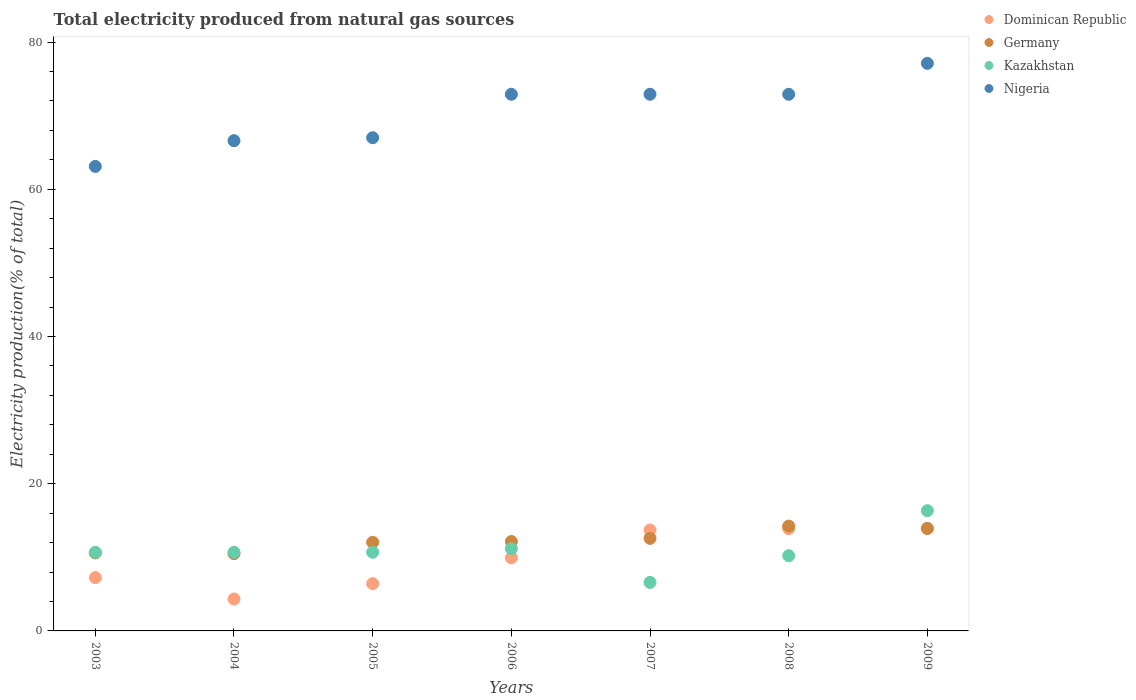What is the total electricity produced in Kazakhstan in 2009?
Your answer should be very brief. 16.33. Across all years, what is the maximum total electricity produced in Germany?
Provide a short and direct response. 14.24. Across all years, what is the minimum total electricity produced in Kazakhstan?
Give a very brief answer. 6.59. What is the total total electricity produced in Nigeria in the graph?
Offer a terse response. 492.5. What is the difference between the total electricity produced in Nigeria in 2007 and that in 2008?
Provide a short and direct response. 0. What is the difference between the total electricity produced in Germany in 2005 and the total electricity produced in Dominican Republic in 2008?
Your answer should be very brief. -1.86. What is the average total electricity produced in Kazakhstan per year?
Offer a very short reply. 10.91. In the year 2007, what is the difference between the total electricity produced in Kazakhstan and total electricity produced in Dominican Republic?
Your answer should be very brief. -7.12. In how many years, is the total electricity produced in Kazakhstan greater than 40 %?
Offer a terse response. 0. What is the ratio of the total electricity produced in Dominican Republic in 2003 to that in 2008?
Offer a very short reply. 0.52. Is the difference between the total electricity produced in Kazakhstan in 2003 and 2006 greater than the difference between the total electricity produced in Dominican Republic in 2003 and 2006?
Provide a succinct answer. Yes. What is the difference between the highest and the second highest total electricity produced in Germany?
Provide a short and direct response. 0.31. What is the difference between the highest and the lowest total electricity produced in Dominican Republic?
Your response must be concise. 9.57. Is the sum of the total electricity produced in Germany in 2003 and 2008 greater than the maximum total electricity produced in Dominican Republic across all years?
Provide a short and direct response. Yes. Is it the case that in every year, the sum of the total electricity produced in Germany and total electricity produced in Kazakhstan  is greater than the total electricity produced in Dominican Republic?
Keep it short and to the point. Yes. Does the total electricity produced in Dominican Republic monotonically increase over the years?
Provide a succinct answer. No. How many years are there in the graph?
Provide a short and direct response. 7. What is the difference between two consecutive major ticks on the Y-axis?
Your answer should be very brief. 20. Are the values on the major ticks of Y-axis written in scientific E-notation?
Your answer should be compact. No. Does the graph contain any zero values?
Keep it short and to the point. No. Does the graph contain grids?
Offer a terse response. No. Where does the legend appear in the graph?
Keep it short and to the point. Top right. How many legend labels are there?
Make the answer very short. 4. What is the title of the graph?
Your answer should be very brief. Total electricity produced from natural gas sources. Does "Guyana" appear as one of the legend labels in the graph?
Your response must be concise. No. What is the label or title of the X-axis?
Your response must be concise. Years. What is the Electricity production(% of total) of Dominican Republic in 2003?
Keep it short and to the point. 7.24. What is the Electricity production(% of total) of Germany in 2003?
Keep it short and to the point. 10.59. What is the Electricity production(% of total) of Kazakhstan in 2003?
Your answer should be very brief. 10.68. What is the Electricity production(% of total) of Nigeria in 2003?
Keep it short and to the point. 63.1. What is the Electricity production(% of total) of Dominican Republic in 2004?
Your answer should be very brief. 4.34. What is the Electricity production(% of total) in Germany in 2004?
Provide a short and direct response. 10.5. What is the Electricity production(% of total) in Kazakhstan in 2004?
Your answer should be compact. 10.68. What is the Electricity production(% of total) of Nigeria in 2004?
Offer a terse response. 66.6. What is the Electricity production(% of total) in Dominican Republic in 2005?
Your answer should be compact. 6.42. What is the Electricity production(% of total) in Germany in 2005?
Give a very brief answer. 12.04. What is the Electricity production(% of total) in Kazakhstan in 2005?
Give a very brief answer. 10.69. What is the Electricity production(% of total) of Nigeria in 2005?
Give a very brief answer. 67. What is the Electricity production(% of total) in Dominican Republic in 2006?
Provide a short and direct response. 9.94. What is the Electricity production(% of total) in Germany in 2006?
Provide a succinct answer. 12.14. What is the Electricity production(% of total) in Kazakhstan in 2006?
Make the answer very short. 11.17. What is the Electricity production(% of total) in Nigeria in 2006?
Make the answer very short. 72.9. What is the Electricity production(% of total) in Dominican Republic in 2007?
Your answer should be very brief. 13.72. What is the Electricity production(% of total) of Germany in 2007?
Give a very brief answer. 12.57. What is the Electricity production(% of total) in Kazakhstan in 2007?
Your answer should be compact. 6.59. What is the Electricity production(% of total) in Nigeria in 2007?
Your answer should be very brief. 72.9. What is the Electricity production(% of total) of Dominican Republic in 2008?
Provide a short and direct response. 13.9. What is the Electricity production(% of total) in Germany in 2008?
Give a very brief answer. 14.24. What is the Electricity production(% of total) in Kazakhstan in 2008?
Your answer should be compact. 10.22. What is the Electricity production(% of total) of Nigeria in 2008?
Your response must be concise. 72.9. What is the Electricity production(% of total) of Dominican Republic in 2009?
Provide a succinct answer. 13.91. What is the Electricity production(% of total) in Germany in 2009?
Your answer should be very brief. 13.93. What is the Electricity production(% of total) in Kazakhstan in 2009?
Your response must be concise. 16.33. What is the Electricity production(% of total) in Nigeria in 2009?
Your answer should be compact. 77.1. Across all years, what is the maximum Electricity production(% of total) in Dominican Republic?
Offer a terse response. 13.91. Across all years, what is the maximum Electricity production(% of total) in Germany?
Your response must be concise. 14.24. Across all years, what is the maximum Electricity production(% of total) of Kazakhstan?
Make the answer very short. 16.33. Across all years, what is the maximum Electricity production(% of total) in Nigeria?
Provide a short and direct response. 77.1. Across all years, what is the minimum Electricity production(% of total) in Dominican Republic?
Offer a very short reply. 4.34. Across all years, what is the minimum Electricity production(% of total) in Germany?
Your answer should be compact. 10.5. Across all years, what is the minimum Electricity production(% of total) of Kazakhstan?
Give a very brief answer. 6.59. Across all years, what is the minimum Electricity production(% of total) of Nigeria?
Provide a succinct answer. 63.1. What is the total Electricity production(% of total) of Dominican Republic in the graph?
Your answer should be very brief. 69.46. What is the total Electricity production(% of total) of Germany in the graph?
Offer a very short reply. 86.02. What is the total Electricity production(% of total) in Kazakhstan in the graph?
Your answer should be very brief. 76.36. What is the total Electricity production(% of total) of Nigeria in the graph?
Offer a very short reply. 492.5. What is the difference between the Electricity production(% of total) in Dominican Republic in 2003 and that in 2004?
Keep it short and to the point. 2.91. What is the difference between the Electricity production(% of total) in Germany in 2003 and that in 2004?
Give a very brief answer. 0.09. What is the difference between the Electricity production(% of total) of Kazakhstan in 2003 and that in 2004?
Make the answer very short. -0. What is the difference between the Electricity production(% of total) in Nigeria in 2003 and that in 2004?
Give a very brief answer. -3.5. What is the difference between the Electricity production(% of total) of Dominican Republic in 2003 and that in 2005?
Your response must be concise. 0.82. What is the difference between the Electricity production(% of total) of Germany in 2003 and that in 2005?
Keep it short and to the point. -1.44. What is the difference between the Electricity production(% of total) of Kazakhstan in 2003 and that in 2005?
Make the answer very short. -0.01. What is the difference between the Electricity production(% of total) of Nigeria in 2003 and that in 2005?
Offer a terse response. -3.9. What is the difference between the Electricity production(% of total) of Dominican Republic in 2003 and that in 2006?
Your answer should be compact. -2.69. What is the difference between the Electricity production(% of total) of Germany in 2003 and that in 2006?
Give a very brief answer. -1.55. What is the difference between the Electricity production(% of total) of Kazakhstan in 2003 and that in 2006?
Offer a very short reply. -0.49. What is the difference between the Electricity production(% of total) of Nigeria in 2003 and that in 2006?
Your answer should be very brief. -9.8. What is the difference between the Electricity production(% of total) of Dominican Republic in 2003 and that in 2007?
Make the answer very short. -6.47. What is the difference between the Electricity production(% of total) of Germany in 2003 and that in 2007?
Offer a terse response. -1.98. What is the difference between the Electricity production(% of total) in Kazakhstan in 2003 and that in 2007?
Your answer should be compact. 4.09. What is the difference between the Electricity production(% of total) in Nigeria in 2003 and that in 2007?
Offer a terse response. -9.8. What is the difference between the Electricity production(% of total) of Dominican Republic in 2003 and that in 2008?
Your answer should be compact. -6.66. What is the difference between the Electricity production(% of total) of Germany in 2003 and that in 2008?
Offer a terse response. -3.65. What is the difference between the Electricity production(% of total) of Kazakhstan in 2003 and that in 2008?
Your answer should be compact. 0.46. What is the difference between the Electricity production(% of total) of Nigeria in 2003 and that in 2008?
Give a very brief answer. -9.8. What is the difference between the Electricity production(% of total) of Dominican Republic in 2003 and that in 2009?
Give a very brief answer. -6.66. What is the difference between the Electricity production(% of total) in Germany in 2003 and that in 2009?
Offer a very short reply. -3.34. What is the difference between the Electricity production(% of total) of Kazakhstan in 2003 and that in 2009?
Keep it short and to the point. -5.66. What is the difference between the Electricity production(% of total) of Nigeria in 2003 and that in 2009?
Keep it short and to the point. -14. What is the difference between the Electricity production(% of total) of Dominican Republic in 2004 and that in 2005?
Offer a very short reply. -2.09. What is the difference between the Electricity production(% of total) of Germany in 2004 and that in 2005?
Your response must be concise. -1.54. What is the difference between the Electricity production(% of total) of Kazakhstan in 2004 and that in 2005?
Your response must be concise. -0.01. What is the difference between the Electricity production(% of total) in Nigeria in 2004 and that in 2005?
Keep it short and to the point. -0.4. What is the difference between the Electricity production(% of total) of Dominican Republic in 2004 and that in 2006?
Offer a very short reply. -5.6. What is the difference between the Electricity production(% of total) of Germany in 2004 and that in 2006?
Provide a succinct answer. -1.64. What is the difference between the Electricity production(% of total) in Kazakhstan in 2004 and that in 2006?
Keep it short and to the point. -0.49. What is the difference between the Electricity production(% of total) of Nigeria in 2004 and that in 2006?
Your answer should be compact. -6.3. What is the difference between the Electricity production(% of total) in Dominican Republic in 2004 and that in 2007?
Make the answer very short. -9.38. What is the difference between the Electricity production(% of total) in Germany in 2004 and that in 2007?
Keep it short and to the point. -2.07. What is the difference between the Electricity production(% of total) of Kazakhstan in 2004 and that in 2007?
Your answer should be very brief. 4.09. What is the difference between the Electricity production(% of total) of Nigeria in 2004 and that in 2007?
Provide a succinct answer. -6.3. What is the difference between the Electricity production(% of total) of Dominican Republic in 2004 and that in 2008?
Make the answer very short. -9.56. What is the difference between the Electricity production(% of total) of Germany in 2004 and that in 2008?
Make the answer very short. -3.74. What is the difference between the Electricity production(% of total) in Kazakhstan in 2004 and that in 2008?
Give a very brief answer. 0.46. What is the difference between the Electricity production(% of total) of Nigeria in 2004 and that in 2008?
Your answer should be very brief. -6.3. What is the difference between the Electricity production(% of total) in Dominican Republic in 2004 and that in 2009?
Provide a succinct answer. -9.57. What is the difference between the Electricity production(% of total) in Germany in 2004 and that in 2009?
Keep it short and to the point. -3.43. What is the difference between the Electricity production(% of total) of Kazakhstan in 2004 and that in 2009?
Your response must be concise. -5.66. What is the difference between the Electricity production(% of total) in Nigeria in 2004 and that in 2009?
Your answer should be compact. -10.5. What is the difference between the Electricity production(% of total) in Dominican Republic in 2005 and that in 2006?
Keep it short and to the point. -3.51. What is the difference between the Electricity production(% of total) in Germany in 2005 and that in 2006?
Offer a terse response. -0.11. What is the difference between the Electricity production(% of total) in Kazakhstan in 2005 and that in 2006?
Provide a succinct answer. -0.48. What is the difference between the Electricity production(% of total) of Nigeria in 2005 and that in 2006?
Ensure brevity in your answer.  -5.9. What is the difference between the Electricity production(% of total) of Dominican Republic in 2005 and that in 2007?
Make the answer very short. -7.29. What is the difference between the Electricity production(% of total) in Germany in 2005 and that in 2007?
Keep it short and to the point. -0.54. What is the difference between the Electricity production(% of total) of Kazakhstan in 2005 and that in 2007?
Offer a terse response. 4.1. What is the difference between the Electricity production(% of total) of Nigeria in 2005 and that in 2007?
Your response must be concise. -5.9. What is the difference between the Electricity production(% of total) in Dominican Republic in 2005 and that in 2008?
Your answer should be very brief. -7.48. What is the difference between the Electricity production(% of total) of Germany in 2005 and that in 2008?
Keep it short and to the point. -2.21. What is the difference between the Electricity production(% of total) in Kazakhstan in 2005 and that in 2008?
Your answer should be very brief. 0.47. What is the difference between the Electricity production(% of total) of Nigeria in 2005 and that in 2008?
Provide a succinct answer. -5.9. What is the difference between the Electricity production(% of total) of Dominican Republic in 2005 and that in 2009?
Your answer should be very brief. -7.48. What is the difference between the Electricity production(% of total) in Germany in 2005 and that in 2009?
Make the answer very short. -1.89. What is the difference between the Electricity production(% of total) of Kazakhstan in 2005 and that in 2009?
Offer a terse response. -5.64. What is the difference between the Electricity production(% of total) in Nigeria in 2005 and that in 2009?
Make the answer very short. -10.1. What is the difference between the Electricity production(% of total) of Dominican Republic in 2006 and that in 2007?
Your answer should be very brief. -3.78. What is the difference between the Electricity production(% of total) in Germany in 2006 and that in 2007?
Make the answer very short. -0.43. What is the difference between the Electricity production(% of total) of Kazakhstan in 2006 and that in 2007?
Keep it short and to the point. 4.58. What is the difference between the Electricity production(% of total) in Nigeria in 2006 and that in 2007?
Provide a succinct answer. -0. What is the difference between the Electricity production(% of total) in Dominican Republic in 2006 and that in 2008?
Provide a succinct answer. -3.96. What is the difference between the Electricity production(% of total) of Germany in 2006 and that in 2008?
Offer a terse response. -2.1. What is the difference between the Electricity production(% of total) of Kazakhstan in 2006 and that in 2008?
Your response must be concise. 0.95. What is the difference between the Electricity production(% of total) of Nigeria in 2006 and that in 2008?
Your answer should be very brief. 0. What is the difference between the Electricity production(% of total) of Dominican Republic in 2006 and that in 2009?
Your answer should be compact. -3.97. What is the difference between the Electricity production(% of total) in Germany in 2006 and that in 2009?
Provide a succinct answer. -1.78. What is the difference between the Electricity production(% of total) of Kazakhstan in 2006 and that in 2009?
Keep it short and to the point. -5.17. What is the difference between the Electricity production(% of total) in Nigeria in 2006 and that in 2009?
Ensure brevity in your answer.  -4.2. What is the difference between the Electricity production(% of total) of Dominican Republic in 2007 and that in 2008?
Your answer should be very brief. -0.18. What is the difference between the Electricity production(% of total) of Germany in 2007 and that in 2008?
Provide a succinct answer. -1.67. What is the difference between the Electricity production(% of total) in Kazakhstan in 2007 and that in 2008?
Your answer should be very brief. -3.63. What is the difference between the Electricity production(% of total) of Nigeria in 2007 and that in 2008?
Keep it short and to the point. 0. What is the difference between the Electricity production(% of total) of Dominican Republic in 2007 and that in 2009?
Offer a very short reply. -0.19. What is the difference between the Electricity production(% of total) in Germany in 2007 and that in 2009?
Your response must be concise. -1.35. What is the difference between the Electricity production(% of total) of Kazakhstan in 2007 and that in 2009?
Make the answer very short. -9.74. What is the difference between the Electricity production(% of total) of Nigeria in 2007 and that in 2009?
Your answer should be very brief. -4.2. What is the difference between the Electricity production(% of total) of Dominican Republic in 2008 and that in 2009?
Give a very brief answer. -0.01. What is the difference between the Electricity production(% of total) in Germany in 2008 and that in 2009?
Keep it short and to the point. 0.31. What is the difference between the Electricity production(% of total) of Kazakhstan in 2008 and that in 2009?
Your response must be concise. -6.12. What is the difference between the Electricity production(% of total) in Nigeria in 2008 and that in 2009?
Your answer should be very brief. -4.2. What is the difference between the Electricity production(% of total) of Dominican Republic in 2003 and the Electricity production(% of total) of Germany in 2004?
Offer a terse response. -3.26. What is the difference between the Electricity production(% of total) of Dominican Republic in 2003 and the Electricity production(% of total) of Kazakhstan in 2004?
Provide a short and direct response. -3.44. What is the difference between the Electricity production(% of total) in Dominican Republic in 2003 and the Electricity production(% of total) in Nigeria in 2004?
Keep it short and to the point. -59.36. What is the difference between the Electricity production(% of total) in Germany in 2003 and the Electricity production(% of total) in Kazakhstan in 2004?
Offer a very short reply. -0.09. What is the difference between the Electricity production(% of total) of Germany in 2003 and the Electricity production(% of total) of Nigeria in 2004?
Make the answer very short. -56.01. What is the difference between the Electricity production(% of total) in Kazakhstan in 2003 and the Electricity production(% of total) in Nigeria in 2004?
Keep it short and to the point. -55.92. What is the difference between the Electricity production(% of total) in Dominican Republic in 2003 and the Electricity production(% of total) in Germany in 2005?
Offer a very short reply. -4.79. What is the difference between the Electricity production(% of total) in Dominican Republic in 2003 and the Electricity production(% of total) in Kazakhstan in 2005?
Offer a very short reply. -3.45. What is the difference between the Electricity production(% of total) of Dominican Republic in 2003 and the Electricity production(% of total) of Nigeria in 2005?
Keep it short and to the point. -59.76. What is the difference between the Electricity production(% of total) in Germany in 2003 and the Electricity production(% of total) in Kazakhstan in 2005?
Offer a very short reply. -0.1. What is the difference between the Electricity production(% of total) of Germany in 2003 and the Electricity production(% of total) of Nigeria in 2005?
Your answer should be very brief. -56.41. What is the difference between the Electricity production(% of total) of Kazakhstan in 2003 and the Electricity production(% of total) of Nigeria in 2005?
Offer a very short reply. -56.32. What is the difference between the Electricity production(% of total) of Dominican Republic in 2003 and the Electricity production(% of total) of Germany in 2006?
Your answer should be compact. -4.9. What is the difference between the Electricity production(% of total) in Dominican Republic in 2003 and the Electricity production(% of total) in Kazakhstan in 2006?
Keep it short and to the point. -3.93. What is the difference between the Electricity production(% of total) in Dominican Republic in 2003 and the Electricity production(% of total) in Nigeria in 2006?
Make the answer very short. -65.66. What is the difference between the Electricity production(% of total) in Germany in 2003 and the Electricity production(% of total) in Kazakhstan in 2006?
Make the answer very short. -0.58. What is the difference between the Electricity production(% of total) in Germany in 2003 and the Electricity production(% of total) in Nigeria in 2006?
Your answer should be compact. -62.31. What is the difference between the Electricity production(% of total) in Kazakhstan in 2003 and the Electricity production(% of total) in Nigeria in 2006?
Your answer should be very brief. -62.22. What is the difference between the Electricity production(% of total) in Dominican Republic in 2003 and the Electricity production(% of total) in Germany in 2007?
Give a very brief answer. -5.33. What is the difference between the Electricity production(% of total) in Dominican Republic in 2003 and the Electricity production(% of total) in Kazakhstan in 2007?
Ensure brevity in your answer.  0.65. What is the difference between the Electricity production(% of total) in Dominican Republic in 2003 and the Electricity production(% of total) in Nigeria in 2007?
Give a very brief answer. -65.66. What is the difference between the Electricity production(% of total) of Germany in 2003 and the Electricity production(% of total) of Kazakhstan in 2007?
Provide a succinct answer. 4. What is the difference between the Electricity production(% of total) of Germany in 2003 and the Electricity production(% of total) of Nigeria in 2007?
Your response must be concise. -62.31. What is the difference between the Electricity production(% of total) in Kazakhstan in 2003 and the Electricity production(% of total) in Nigeria in 2007?
Your response must be concise. -62.22. What is the difference between the Electricity production(% of total) in Dominican Republic in 2003 and the Electricity production(% of total) in Germany in 2008?
Ensure brevity in your answer.  -7. What is the difference between the Electricity production(% of total) in Dominican Republic in 2003 and the Electricity production(% of total) in Kazakhstan in 2008?
Make the answer very short. -2.97. What is the difference between the Electricity production(% of total) in Dominican Republic in 2003 and the Electricity production(% of total) in Nigeria in 2008?
Your response must be concise. -65.66. What is the difference between the Electricity production(% of total) of Germany in 2003 and the Electricity production(% of total) of Kazakhstan in 2008?
Offer a very short reply. 0.38. What is the difference between the Electricity production(% of total) of Germany in 2003 and the Electricity production(% of total) of Nigeria in 2008?
Offer a terse response. -62.31. What is the difference between the Electricity production(% of total) in Kazakhstan in 2003 and the Electricity production(% of total) in Nigeria in 2008?
Provide a short and direct response. -62.22. What is the difference between the Electricity production(% of total) of Dominican Republic in 2003 and the Electricity production(% of total) of Germany in 2009?
Your response must be concise. -6.69. What is the difference between the Electricity production(% of total) of Dominican Republic in 2003 and the Electricity production(% of total) of Kazakhstan in 2009?
Offer a very short reply. -9.09. What is the difference between the Electricity production(% of total) in Dominican Republic in 2003 and the Electricity production(% of total) in Nigeria in 2009?
Offer a terse response. -69.86. What is the difference between the Electricity production(% of total) of Germany in 2003 and the Electricity production(% of total) of Kazakhstan in 2009?
Offer a terse response. -5.74. What is the difference between the Electricity production(% of total) in Germany in 2003 and the Electricity production(% of total) in Nigeria in 2009?
Offer a terse response. -66.51. What is the difference between the Electricity production(% of total) in Kazakhstan in 2003 and the Electricity production(% of total) in Nigeria in 2009?
Your answer should be very brief. -66.42. What is the difference between the Electricity production(% of total) of Dominican Republic in 2004 and the Electricity production(% of total) of Germany in 2005?
Your answer should be compact. -7.7. What is the difference between the Electricity production(% of total) in Dominican Republic in 2004 and the Electricity production(% of total) in Kazakhstan in 2005?
Keep it short and to the point. -6.35. What is the difference between the Electricity production(% of total) in Dominican Republic in 2004 and the Electricity production(% of total) in Nigeria in 2005?
Offer a very short reply. -62.66. What is the difference between the Electricity production(% of total) of Germany in 2004 and the Electricity production(% of total) of Kazakhstan in 2005?
Your answer should be very brief. -0.19. What is the difference between the Electricity production(% of total) of Germany in 2004 and the Electricity production(% of total) of Nigeria in 2005?
Provide a short and direct response. -56.5. What is the difference between the Electricity production(% of total) in Kazakhstan in 2004 and the Electricity production(% of total) in Nigeria in 2005?
Your answer should be very brief. -56.32. What is the difference between the Electricity production(% of total) of Dominican Republic in 2004 and the Electricity production(% of total) of Germany in 2006?
Give a very brief answer. -7.81. What is the difference between the Electricity production(% of total) in Dominican Republic in 2004 and the Electricity production(% of total) in Kazakhstan in 2006?
Offer a terse response. -6.83. What is the difference between the Electricity production(% of total) in Dominican Republic in 2004 and the Electricity production(% of total) in Nigeria in 2006?
Provide a short and direct response. -68.56. What is the difference between the Electricity production(% of total) in Germany in 2004 and the Electricity production(% of total) in Kazakhstan in 2006?
Your response must be concise. -0.67. What is the difference between the Electricity production(% of total) in Germany in 2004 and the Electricity production(% of total) in Nigeria in 2006?
Keep it short and to the point. -62.4. What is the difference between the Electricity production(% of total) in Kazakhstan in 2004 and the Electricity production(% of total) in Nigeria in 2006?
Provide a succinct answer. -62.22. What is the difference between the Electricity production(% of total) in Dominican Republic in 2004 and the Electricity production(% of total) in Germany in 2007?
Your response must be concise. -8.24. What is the difference between the Electricity production(% of total) of Dominican Republic in 2004 and the Electricity production(% of total) of Kazakhstan in 2007?
Keep it short and to the point. -2.25. What is the difference between the Electricity production(% of total) of Dominican Republic in 2004 and the Electricity production(% of total) of Nigeria in 2007?
Your answer should be compact. -68.56. What is the difference between the Electricity production(% of total) of Germany in 2004 and the Electricity production(% of total) of Kazakhstan in 2007?
Give a very brief answer. 3.91. What is the difference between the Electricity production(% of total) of Germany in 2004 and the Electricity production(% of total) of Nigeria in 2007?
Provide a succinct answer. -62.4. What is the difference between the Electricity production(% of total) in Kazakhstan in 2004 and the Electricity production(% of total) in Nigeria in 2007?
Offer a very short reply. -62.22. What is the difference between the Electricity production(% of total) of Dominican Republic in 2004 and the Electricity production(% of total) of Germany in 2008?
Keep it short and to the point. -9.91. What is the difference between the Electricity production(% of total) in Dominican Republic in 2004 and the Electricity production(% of total) in Kazakhstan in 2008?
Ensure brevity in your answer.  -5.88. What is the difference between the Electricity production(% of total) of Dominican Republic in 2004 and the Electricity production(% of total) of Nigeria in 2008?
Provide a succinct answer. -68.56. What is the difference between the Electricity production(% of total) of Germany in 2004 and the Electricity production(% of total) of Kazakhstan in 2008?
Offer a terse response. 0.28. What is the difference between the Electricity production(% of total) in Germany in 2004 and the Electricity production(% of total) in Nigeria in 2008?
Give a very brief answer. -62.4. What is the difference between the Electricity production(% of total) in Kazakhstan in 2004 and the Electricity production(% of total) in Nigeria in 2008?
Provide a succinct answer. -62.22. What is the difference between the Electricity production(% of total) in Dominican Republic in 2004 and the Electricity production(% of total) in Germany in 2009?
Your answer should be compact. -9.59. What is the difference between the Electricity production(% of total) in Dominican Republic in 2004 and the Electricity production(% of total) in Kazakhstan in 2009?
Make the answer very short. -12. What is the difference between the Electricity production(% of total) in Dominican Republic in 2004 and the Electricity production(% of total) in Nigeria in 2009?
Your answer should be very brief. -72.76. What is the difference between the Electricity production(% of total) in Germany in 2004 and the Electricity production(% of total) in Kazakhstan in 2009?
Provide a succinct answer. -5.83. What is the difference between the Electricity production(% of total) in Germany in 2004 and the Electricity production(% of total) in Nigeria in 2009?
Make the answer very short. -66.6. What is the difference between the Electricity production(% of total) in Kazakhstan in 2004 and the Electricity production(% of total) in Nigeria in 2009?
Your response must be concise. -66.42. What is the difference between the Electricity production(% of total) of Dominican Republic in 2005 and the Electricity production(% of total) of Germany in 2006?
Your answer should be very brief. -5.72. What is the difference between the Electricity production(% of total) of Dominican Republic in 2005 and the Electricity production(% of total) of Kazakhstan in 2006?
Your answer should be compact. -4.75. What is the difference between the Electricity production(% of total) in Dominican Republic in 2005 and the Electricity production(% of total) in Nigeria in 2006?
Your response must be concise. -66.48. What is the difference between the Electricity production(% of total) in Germany in 2005 and the Electricity production(% of total) in Kazakhstan in 2006?
Give a very brief answer. 0.87. What is the difference between the Electricity production(% of total) in Germany in 2005 and the Electricity production(% of total) in Nigeria in 2006?
Your answer should be very brief. -60.86. What is the difference between the Electricity production(% of total) of Kazakhstan in 2005 and the Electricity production(% of total) of Nigeria in 2006?
Offer a very short reply. -62.21. What is the difference between the Electricity production(% of total) in Dominican Republic in 2005 and the Electricity production(% of total) in Germany in 2007?
Give a very brief answer. -6.15. What is the difference between the Electricity production(% of total) of Dominican Republic in 2005 and the Electricity production(% of total) of Kazakhstan in 2007?
Your response must be concise. -0.17. What is the difference between the Electricity production(% of total) in Dominican Republic in 2005 and the Electricity production(% of total) in Nigeria in 2007?
Keep it short and to the point. -66.48. What is the difference between the Electricity production(% of total) in Germany in 2005 and the Electricity production(% of total) in Kazakhstan in 2007?
Offer a very short reply. 5.45. What is the difference between the Electricity production(% of total) in Germany in 2005 and the Electricity production(% of total) in Nigeria in 2007?
Provide a short and direct response. -60.86. What is the difference between the Electricity production(% of total) of Kazakhstan in 2005 and the Electricity production(% of total) of Nigeria in 2007?
Make the answer very short. -62.21. What is the difference between the Electricity production(% of total) of Dominican Republic in 2005 and the Electricity production(% of total) of Germany in 2008?
Keep it short and to the point. -7.82. What is the difference between the Electricity production(% of total) in Dominican Republic in 2005 and the Electricity production(% of total) in Kazakhstan in 2008?
Provide a succinct answer. -3.79. What is the difference between the Electricity production(% of total) in Dominican Republic in 2005 and the Electricity production(% of total) in Nigeria in 2008?
Keep it short and to the point. -66.48. What is the difference between the Electricity production(% of total) of Germany in 2005 and the Electricity production(% of total) of Kazakhstan in 2008?
Offer a very short reply. 1.82. What is the difference between the Electricity production(% of total) of Germany in 2005 and the Electricity production(% of total) of Nigeria in 2008?
Ensure brevity in your answer.  -60.86. What is the difference between the Electricity production(% of total) in Kazakhstan in 2005 and the Electricity production(% of total) in Nigeria in 2008?
Provide a succinct answer. -62.21. What is the difference between the Electricity production(% of total) of Dominican Republic in 2005 and the Electricity production(% of total) of Germany in 2009?
Your answer should be compact. -7.51. What is the difference between the Electricity production(% of total) of Dominican Republic in 2005 and the Electricity production(% of total) of Kazakhstan in 2009?
Offer a very short reply. -9.91. What is the difference between the Electricity production(% of total) in Dominican Republic in 2005 and the Electricity production(% of total) in Nigeria in 2009?
Your response must be concise. -70.68. What is the difference between the Electricity production(% of total) of Germany in 2005 and the Electricity production(% of total) of Kazakhstan in 2009?
Offer a very short reply. -4.3. What is the difference between the Electricity production(% of total) of Germany in 2005 and the Electricity production(% of total) of Nigeria in 2009?
Give a very brief answer. -65.06. What is the difference between the Electricity production(% of total) of Kazakhstan in 2005 and the Electricity production(% of total) of Nigeria in 2009?
Provide a short and direct response. -66.41. What is the difference between the Electricity production(% of total) in Dominican Republic in 2006 and the Electricity production(% of total) in Germany in 2007?
Ensure brevity in your answer.  -2.64. What is the difference between the Electricity production(% of total) in Dominican Republic in 2006 and the Electricity production(% of total) in Kazakhstan in 2007?
Offer a very short reply. 3.34. What is the difference between the Electricity production(% of total) of Dominican Republic in 2006 and the Electricity production(% of total) of Nigeria in 2007?
Your answer should be compact. -62.97. What is the difference between the Electricity production(% of total) of Germany in 2006 and the Electricity production(% of total) of Kazakhstan in 2007?
Provide a succinct answer. 5.55. What is the difference between the Electricity production(% of total) in Germany in 2006 and the Electricity production(% of total) in Nigeria in 2007?
Provide a short and direct response. -60.76. What is the difference between the Electricity production(% of total) of Kazakhstan in 2006 and the Electricity production(% of total) of Nigeria in 2007?
Give a very brief answer. -61.73. What is the difference between the Electricity production(% of total) in Dominican Republic in 2006 and the Electricity production(% of total) in Germany in 2008?
Your answer should be very brief. -4.31. What is the difference between the Electricity production(% of total) of Dominican Republic in 2006 and the Electricity production(% of total) of Kazakhstan in 2008?
Your answer should be compact. -0.28. What is the difference between the Electricity production(% of total) of Dominican Republic in 2006 and the Electricity production(% of total) of Nigeria in 2008?
Your answer should be very brief. -62.96. What is the difference between the Electricity production(% of total) in Germany in 2006 and the Electricity production(% of total) in Kazakhstan in 2008?
Offer a terse response. 1.93. What is the difference between the Electricity production(% of total) of Germany in 2006 and the Electricity production(% of total) of Nigeria in 2008?
Make the answer very short. -60.76. What is the difference between the Electricity production(% of total) in Kazakhstan in 2006 and the Electricity production(% of total) in Nigeria in 2008?
Ensure brevity in your answer.  -61.73. What is the difference between the Electricity production(% of total) in Dominican Republic in 2006 and the Electricity production(% of total) in Germany in 2009?
Keep it short and to the point. -3.99. What is the difference between the Electricity production(% of total) in Dominican Republic in 2006 and the Electricity production(% of total) in Kazakhstan in 2009?
Give a very brief answer. -6.4. What is the difference between the Electricity production(% of total) in Dominican Republic in 2006 and the Electricity production(% of total) in Nigeria in 2009?
Ensure brevity in your answer.  -67.16. What is the difference between the Electricity production(% of total) in Germany in 2006 and the Electricity production(% of total) in Kazakhstan in 2009?
Give a very brief answer. -4.19. What is the difference between the Electricity production(% of total) in Germany in 2006 and the Electricity production(% of total) in Nigeria in 2009?
Offer a terse response. -64.96. What is the difference between the Electricity production(% of total) of Kazakhstan in 2006 and the Electricity production(% of total) of Nigeria in 2009?
Keep it short and to the point. -65.93. What is the difference between the Electricity production(% of total) of Dominican Republic in 2007 and the Electricity production(% of total) of Germany in 2008?
Provide a succinct answer. -0.53. What is the difference between the Electricity production(% of total) in Dominican Republic in 2007 and the Electricity production(% of total) in Kazakhstan in 2008?
Your answer should be very brief. 3.5. What is the difference between the Electricity production(% of total) in Dominican Republic in 2007 and the Electricity production(% of total) in Nigeria in 2008?
Your response must be concise. -59.18. What is the difference between the Electricity production(% of total) of Germany in 2007 and the Electricity production(% of total) of Kazakhstan in 2008?
Your answer should be very brief. 2.36. What is the difference between the Electricity production(% of total) in Germany in 2007 and the Electricity production(% of total) in Nigeria in 2008?
Keep it short and to the point. -60.33. What is the difference between the Electricity production(% of total) in Kazakhstan in 2007 and the Electricity production(% of total) in Nigeria in 2008?
Provide a succinct answer. -66.31. What is the difference between the Electricity production(% of total) in Dominican Republic in 2007 and the Electricity production(% of total) in Germany in 2009?
Provide a succinct answer. -0.21. What is the difference between the Electricity production(% of total) in Dominican Republic in 2007 and the Electricity production(% of total) in Kazakhstan in 2009?
Your answer should be very brief. -2.62. What is the difference between the Electricity production(% of total) in Dominican Republic in 2007 and the Electricity production(% of total) in Nigeria in 2009?
Give a very brief answer. -63.38. What is the difference between the Electricity production(% of total) in Germany in 2007 and the Electricity production(% of total) in Kazakhstan in 2009?
Keep it short and to the point. -3.76. What is the difference between the Electricity production(% of total) in Germany in 2007 and the Electricity production(% of total) in Nigeria in 2009?
Keep it short and to the point. -64.53. What is the difference between the Electricity production(% of total) of Kazakhstan in 2007 and the Electricity production(% of total) of Nigeria in 2009?
Your response must be concise. -70.51. What is the difference between the Electricity production(% of total) in Dominican Republic in 2008 and the Electricity production(% of total) in Germany in 2009?
Provide a succinct answer. -0.03. What is the difference between the Electricity production(% of total) in Dominican Republic in 2008 and the Electricity production(% of total) in Kazakhstan in 2009?
Your answer should be very brief. -2.44. What is the difference between the Electricity production(% of total) in Dominican Republic in 2008 and the Electricity production(% of total) in Nigeria in 2009?
Provide a short and direct response. -63.2. What is the difference between the Electricity production(% of total) of Germany in 2008 and the Electricity production(% of total) of Kazakhstan in 2009?
Offer a very short reply. -2.09. What is the difference between the Electricity production(% of total) of Germany in 2008 and the Electricity production(% of total) of Nigeria in 2009?
Your response must be concise. -62.86. What is the difference between the Electricity production(% of total) in Kazakhstan in 2008 and the Electricity production(% of total) in Nigeria in 2009?
Make the answer very short. -66.88. What is the average Electricity production(% of total) in Dominican Republic per year?
Make the answer very short. 9.92. What is the average Electricity production(% of total) of Germany per year?
Provide a short and direct response. 12.29. What is the average Electricity production(% of total) of Kazakhstan per year?
Offer a terse response. 10.91. What is the average Electricity production(% of total) in Nigeria per year?
Ensure brevity in your answer.  70.36. In the year 2003, what is the difference between the Electricity production(% of total) in Dominican Republic and Electricity production(% of total) in Germany?
Give a very brief answer. -3.35. In the year 2003, what is the difference between the Electricity production(% of total) in Dominican Republic and Electricity production(% of total) in Kazakhstan?
Offer a terse response. -3.44. In the year 2003, what is the difference between the Electricity production(% of total) of Dominican Republic and Electricity production(% of total) of Nigeria?
Keep it short and to the point. -55.86. In the year 2003, what is the difference between the Electricity production(% of total) in Germany and Electricity production(% of total) in Kazakhstan?
Provide a short and direct response. -0.09. In the year 2003, what is the difference between the Electricity production(% of total) in Germany and Electricity production(% of total) in Nigeria?
Make the answer very short. -52.51. In the year 2003, what is the difference between the Electricity production(% of total) in Kazakhstan and Electricity production(% of total) in Nigeria?
Offer a terse response. -52.42. In the year 2004, what is the difference between the Electricity production(% of total) of Dominican Republic and Electricity production(% of total) of Germany?
Give a very brief answer. -6.16. In the year 2004, what is the difference between the Electricity production(% of total) of Dominican Republic and Electricity production(% of total) of Kazakhstan?
Your answer should be compact. -6.34. In the year 2004, what is the difference between the Electricity production(% of total) of Dominican Republic and Electricity production(% of total) of Nigeria?
Provide a succinct answer. -62.26. In the year 2004, what is the difference between the Electricity production(% of total) of Germany and Electricity production(% of total) of Kazakhstan?
Give a very brief answer. -0.18. In the year 2004, what is the difference between the Electricity production(% of total) in Germany and Electricity production(% of total) in Nigeria?
Keep it short and to the point. -56.1. In the year 2004, what is the difference between the Electricity production(% of total) of Kazakhstan and Electricity production(% of total) of Nigeria?
Make the answer very short. -55.92. In the year 2005, what is the difference between the Electricity production(% of total) of Dominican Republic and Electricity production(% of total) of Germany?
Offer a very short reply. -5.61. In the year 2005, what is the difference between the Electricity production(% of total) of Dominican Republic and Electricity production(% of total) of Kazakhstan?
Give a very brief answer. -4.27. In the year 2005, what is the difference between the Electricity production(% of total) of Dominican Republic and Electricity production(% of total) of Nigeria?
Provide a succinct answer. -60.58. In the year 2005, what is the difference between the Electricity production(% of total) of Germany and Electricity production(% of total) of Kazakhstan?
Provide a succinct answer. 1.35. In the year 2005, what is the difference between the Electricity production(% of total) in Germany and Electricity production(% of total) in Nigeria?
Offer a very short reply. -54.96. In the year 2005, what is the difference between the Electricity production(% of total) in Kazakhstan and Electricity production(% of total) in Nigeria?
Make the answer very short. -56.31. In the year 2006, what is the difference between the Electricity production(% of total) of Dominican Republic and Electricity production(% of total) of Germany?
Give a very brief answer. -2.21. In the year 2006, what is the difference between the Electricity production(% of total) of Dominican Republic and Electricity production(% of total) of Kazakhstan?
Your response must be concise. -1.23. In the year 2006, what is the difference between the Electricity production(% of total) in Dominican Republic and Electricity production(% of total) in Nigeria?
Make the answer very short. -62.96. In the year 2006, what is the difference between the Electricity production(% of total) in Germany and Electricity production(% of total) in Kazakhstan?
Keep it short and to the point. 0.98. In the year 2006, what is the difference between the Electricity production(% of total) in Germany and Electricity production(% of total) in Nigeria?
Offer a terse response. -60.76. In the year 2006, what is the difference between the Electricity production(% of total) of Kazakhstan and Electricity production(% of total) of Nigeria?
Your response must be concise. -61.73. In the year 2007, what is the difference between the Electricity production(% of total) in Dominican Republic and Electricity production(% of total) in Germany?
Make the answer very short. 1.14. In the year 2007, what is the difference between the Electricity production(% of total) in Dominican Republic and Electricity production(% of total) in Kazakhstan?
Your answer should be very brief. 7.12. In the year 2007, what is the difference between the Electricity production(% of total) in Dominican Republic and Electricity production(% of total) in Nigeria?
Offer a very short reply. -59.18. In the year 2007, what is the difference between the Electricity production(% of total) of Germany and Electricity production(% of total) of Kazakhstan?
Make the answer very short. 5.98. In the year 2007, what is the difference between the Electricity production(% of total) of Germany and Electricity production(% of total) of Nigeria?
Ensure brevity in your answer.  -60.33. In the year 2007, what is the difference between the Electricity production(% of total) in Kazakhstan and Electricity production(% of total) in Nigeria?
Provide a succinct answer. -66.31. In the year 2008, what is the difference between the Electricity production(% of total) of Dominican Republic and Electricity production(% of total) of Germany?
Offer a very short reply. -0.34. In the year 2008, what is the difference between the Electricity production(% of total) of Dominican Republic and Electricity production(% of total) of Kazakhstan?
Keep it short and to the point. 3.68. In the year 2008, what is the difference between the Electricity production(% of total) in Dominican Republic and Electricity production(% of total) in Nigeria?
Keep it short and to the point. -59. In the year 2008, what is the difference between the Electricity production(% of total) in Germany and Electricity production(% of total) in Kazakhstan?
Your answer should be very brief. 4.03. In the year 2008, what is the difference between the Electricity production(% of total) in Germany and Electricity production(% of total) in Nigeria?
Ensure brevity in your answer.  -58.66. In the year 2008, what is the difference between the Electricity production(% of total) in Kazakhstan and Electricity production(% of total) in Nigeria?
Offer a terse response. -62.68. In the year 2009, what is the difference between the Electricity production(% of total) of Dominican Republic and Electricity production(% of total) of Germany?
Your answer should be very brief. -0.02. In the year 2009, what is the difference between the Electricity production(% of total) in Dominican Republic and Electricity production(% of total) in Kazakhstan?
Your response must be concise. -2.43. In the year 2009, what is the difference between the Electricity production(% of total) in Dominican Republic and Electricity production(% of total) in Nigeria?
Make the answer very short. -63.19. In the year 2009, what is the difference between the Electricity production(% of total) of Germany and Electricity production(% of total) of Kazakhstan?
Offer a terse response. -2.41. In the year 2009, what is the difference between the Electricity production(% of total) of Germany and Electricity production(% of total) of Nigeria?
Your response must be concise. -63.17. In the year 2009, what is the difference between the Electricity production(% of total) of Kazakhstan and Electricity production(% of total) of Nigeria?
Offer a very short reply. -60.77. What is the ratio of the Electricity production(% of total) of Dominican Republic in 2003 to that in 2004?
Offer a very short reply. 1.67. What is the ratio of the Electricity production(% of total) of Germany in 2003 to that in 2004?
Offer a terse response. 1.01. What is the ratio of the Electricity production(% of total) of Kazakhstan in 2003 to that in 2004?
Your response must be concise. 1. What is the ratio of the Electricity production(% of total) of Dominican Republic in 2003 to that in 2005?
Your answer should be very brief. 1.13. What is the ratio of the Electricity production(% of total) in Germany in 2003 to that in 2005?
Your answer should be very brief. 0.88. What is the ratio of the Electricity production(% of total) of Kazakhstan in 2003 to that in 2005?
Give a very brief answer. 1. What is the ratio of the Electricity production(% of total) of Nigeria in 2003 to that in 2005?
Give a very brief answer. 0.94. What is the ratio of the Electricity production(% of total) of Dominican Republic in 2003 to that in 2006?
Keep it short and to the point. 0.73. What is the ratio of the Electricity production(% of total) in Germany in 2003 to that in 2006?
Your answer should be compact. 0.87. What is the ratio of the Electricity production(% of total) of Kazakhstan in 2003 to that in 2006?
Ensure brevity in your answer.  0.96. What is the ratio of the Electricity production(% of total) of Nigeria in 2003 to that in 2006?
Provide a short and direct response. 0.87. What is the ratio of the Electricity production(% of total) in Dominican Republic in 2003 to that in 2007?
Your answer should be very brief. 0.53. What is the ratio of the Electricity production(% of total) of Germany in 2003 to that in 2007?
Make the answer very short. 0.84. What is the ratio of the Electricity production(% of total) in Kazakhstan in 2003 to that in 2007?
Offer a terse response. 1.62. What is the ratio of the Electricity production(% of total) in Nigeria in 2003 to that in 2007?
Provide a succinct answer. 0.87. What is the ratio of the Electricity production(% of total) in Dominican Republic in 2003 to that in 2008?
Provide a succinct answer. 0.52. What is the ratio of the Electricity production(% of total) in Germany in 2003 to that in 2008?
Your response must be concise. 0.74. What is the ratio of the Electricity production(% of total) of Kazakhstan in 2003 to that in 2008?
Make the answer very short. 1.05. What is the ratio of the Electricity production(% of total) of Nigeria in 2003 to that in 2008?
Provide a short and direct response. 0.87. What is the ratio of the Electricity production(% of total) in Dominican Republic in 2003 to that in 2009?
Keep it short and to the point. 0.52. What is the ratio of the Electricity production(% of total) of Germany in 2003 to that in 2009?
Provide a short and direct response. 0.76. What is the ratio of the Electricity production(% of total) of Kazakhstan in 2003 to that in 2009?
Your answer should be very brief. 0.65. What is the ratio of the Electricity production(% of total) of Nigeria in 2003 to that in 2009?
Provide a short and direct response. 0.82. What is the ratio of the Electricity production(% of total) in Dominican Republic in 2004 to that in 2005?
Your answer should be compact. 0.68. What is the ratio of the Electricity production(% of total) in Germany in 2004 to that in 2005?
Provide a short and direct response. 0.87. What is the ratio of the Electricity production(% of total) of Kazakhstan in 2004 to that in 2005?
Your response must be concise. 1. What is the ratio of the Electricity production(% of total) in Nigeria in 2004 to that in 2005?
Ensure brevity in your answer.  0.99. What is the ratio of the Electricity production(% of total) of Dominican Republic in 2004 to that in 2006?
Give a very brief answer. 0.44. What is the ratio of the Electricity production(% of total) of Germany in 2004 to that in 2006?
Your answer should be very brief. 0.86. What is the ratio of the Electricity production(% of total) in Kazakhstan in 2004 to that in 2006?
Give a very brief answer. 0.96. What is the ratio of the Electricity production(% of total) in Nigeria in 2004 to that in 2006?
Ensure brevity in your answer.  0.91. What is the ratio of the Electricity production(% of total) in Dominican Republic in 2004 to that in 2007?
Give a very brief answer. 0.32. What is the ratio of the Electricity production(% of total) in Germany in 2004 to that in 2007?
Your answer should be compact. 0.84. What is the ratio of the Electricity production(% of total) in Kazakhstan in 2004 to that in 2007?
Give a very brief answer. 1.62. What is the ratio of the Electricity production(% of total) of Nigeria in 2004 to that in 2007?
Make the answer very short. 0.91. What is the ratio of the Electricity production(% of total) in Dominican Republic in 2004 to that in 2008?
Offer a terse response. 0.31. What is the ratio of the Electricity production(% of total) of Germany in 2004 to that in 2008?
Your answer should be compact. 0.74. What is the ratio of the Electricity production(% of total) of Kazakhstan in 2004 to that in 2008?
Ensure brevity in your answer.  1.05. What is the ratio of the Electricity production(% of total) in Nigeria in 2004 to that in 2008?
Give a very brief answer. 0.91. What is the ratio of the Electricity production(% of total) in Dominican Republic in 2004 to that in 2009?
Ensure brevity in your answer.  0.31. What is the ratio of the Electricity production(% of total) of Germany in 2004 to that in 2009?
Provide a short and direct response. 0.75. What is the ratio of the Electricity production(% of total) in Kazakhstan in 2004 to that in 2009?
Provide a short and direct response. 0.65. What is the ratio of the Electricity production(% of total) of Nigeria in 2004 to that in 2009?
Your response must be concise. 0.86. What is the ratio of the Electricity production(% of total) in Dominican Republic in 2005 to that in 2006?
Provide a short and direct response. 0.65. What is the ratio of the Electricity production(% of total) of Germany in 2005 to that in 2006?
Ensure brevity in your answer.  0.99. What is the ratio of the Electricity production(% of total) of Kazakhstan in 2005 to that in 2006?
Your answer should be compact. 0.96. What is the ratio of the Electricity production(% of total) in Nigeria in 2005 to that in 2006?
Provide a succinct answer. 0.92. What is the ratio of the Electricity production(% of total) in Dominican Republic in 2005 to that in 2007?
Ensure brevity in your answer.  0.47. What is the ratio of the Electricity production(% of total) in Germany in 2005 to that in 2007?
Provide a succinct answer. 0.96. What is the ratio of the Electricity production(% of total) of Kazakhstan in 2005 to that in 2007?
Your response must be concise. 1.62. What is the ratio of the Electricity production(% of total) of Nigeria in 2005 to that in 2007?
Your answer should be very brief. 0.92. What is the ratio of the Electricity production(% of total) of Dominican Republic in 2005 to that in 2008?
Keep it short and to the point. 0.46. What is the ratio of the Electricity production(% of total) in Germany in 2005 to that in 2008?
Give a very brief answer. 0.84. What is the ratio of the Electricity production(% of total) of Kazakhstan in 2005 to that in 2008?
Give a very brief answer. 1.05. What is the ratio of the Electricity production(% of total) of Nigeria in 2005 to that in 2008?
Ensure brevity in your answer.  0.92. What is the ratio of the Electricity production(% of total) of Dominican Republic in 2005 to that in 2009?
Make the answer very short. 0.46. What is the ratio of the Electricity production(% of total) in Germany in 2005 to that in 2009?
Offer a very short reply. 0.86. What is the ratio of the Electricity production(% of total) in Kazakhstan in 2005 to that in 2009?
Give a very brief answer. 0.65. What is the ratio of the Electricity production(% of total) in Nigeria in 2005 to that in 2009?
Ensure brevity in your answer.  0.87. What is the ratio of the Electricity production(% of total) of Dominican Republic in 2006 to that in 2007?
Offer a very short reply. 0.72. What is the ratio of the Electricity production(% of total) of Germany in 2006 to that in 2007?
Make the answer very short. 0.97. What is the ratio of the Electricity production(% of total) in Kazakhstan in 2006 to that in 2007?
Offer a terse response. 1.69. What is the ratio of the Electricity production(% of total) in Nigeria in 2006 to that in 2007?
Provide a succinct answer. 1. What is the ratio of the Electricity production(% of total) of Dominican Republic in 2006 to that in 2008?
Keep it short and to the point. 0.71. What is the ratio of the Electricity production(% of total) in Germany in 2006 to that in 2008?
Provide a succinct answer. 0.85. What is the ratio of the Electricity production(% of total) in Kazakhstan in 2006 to that in 2008?
Your answer should be compact. 1.09. What is the ratio of the Electricity production(% of total) of Dominican Republic in 2006 to that in 2009?
Ensure brevity in your answer.  0.71. What is the ratio of the Electricity production(% of total) in Germany in 2006 to that in 2009?
Provide a short and direct response. 0.87. What is the ratio of the Electricity production(% of total) of Kazakhstan in 2006 to that in 2009?
Provide a succinct answer. 0.68. What is the ratio of the Electricity production(% of total) of Nigeria in 2006 to that in 2009?
Give a very brief answer. 0.95. What is the ratio of the Electricity production(% of total) of Dominican Republic in 2007 to that in 2008?
Your answer should be very brief. 0.99. What is the ratio of the Electricity production(% of total) in Germany in 2007 to that in 2008?
Provide a succinct answer. 0.88. What is the ratio of the Electricity production(% of total) of Kazakhstan in 2007 to that in 2008?
Your answer should be compact. 0.65. What is the ratio of the Electricity production(% of total) in Dominican Republic in 2007 to that in 2009?
Give a very brief answer. 0.99. What is the ratio of the Electricity production(% of total) of Germany in 2007 to that in 2009?
Provide a succinct answer. 0.9. What is the ratio of the Electricity production(% of total) of Kazakhstan in 2007 to that in 2009?
Make the answer very short. 0.4. What is the ratio of the Electricity production(% of total) in Nigeria in 2007 to that in 2009?
Give a very brief answer. 0.95. What is the ratio of the Electricity production(% of total) of Germany in 2008 to that in 2009?
Make the answer very short. 1.02. What is the ratio of the Electricity production(% of total) of Kazakhstan in 2008 to that in 2009?
Make the answer very short. 0.63. What is the ratio of the Electricity production(% of total) of Nigeria in 2008 to that in 2009?
Provide a short and direct response. 0.95. What is the difference between the highest and the second highest Electricity production(% of total) in Dominican Republic?
Make the answer very short. 0.01. What is the difference between the highest and the second highest Electricity production(% of total) in Germany?
Provide a short and direct response. 0.31. What is the difference between the highest and the second highest Electricity production(% of total) of Kazakhstan?
Your answer should be very brief. 5.17. What is the difference between the highest and the second highest Electricity production(% of total) of Nigeria?
Your answer should be compact. 4.2. What is the difference between the highest and the lowest Electricity production(% of total) in Dominican Republic?
Your response must be concise. 9.57. What is the difference between the highest and the lowest Electricity production(% of total) in Germany?
Keep it short and to the point. 3.74. What is the difference between the highest and the lowest Electricity production(% of total) in Kazakhstan?
Offer a very short reply. 9.74. What is the difference between the highest and the lowest Electricity production(% of total) of Nigeria?
Your answer should be very brief. 14. 